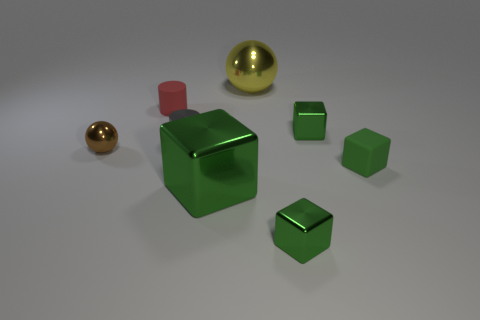Are there fewer big objects in front of the tiny red object than yellow balls left of the large green metal thing?
Your response must be concise. No. Is the red rubber object the same size as the gray cylinder?
Give a very brief answer. Yes. There is a metallic thing that is behind the tiny gray object and in front of the yellow shiny object; what is its shape?
Your answer should be very brief. Cube. What number of small balls are made of the same material as the yellow thing?
Provide a short and direct response. 1. There is a small block behind the green rubber cube; how many green metallic blocks are on the left side of it?
Offer a very short reply. 2. There is a rubber thing that is behind the tiny green block that is behind the shiny ball on the left side of the small metallic cylinder; what shape is it?
Your answer should be compact. Cylinder. What size is the other matte block that is the same color as the big cube?
Make the answer very short. Small. What number of objects are either small red rubber objects or tiny brown balls?
Ensure brevity in your answer.  2. What color is the matte cube that is the same size as the brown metal ball?
Make the answer very short. Green. There is a big yellow shiny thing; does it have the same shape as the green matte thing that is right of the brown shiny thing?
Offer a very short reply. No. 